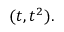<formula> <loc_0><loc_0><loc_500><loc_500>( t , t ^ { 2 } ) .</formula> 